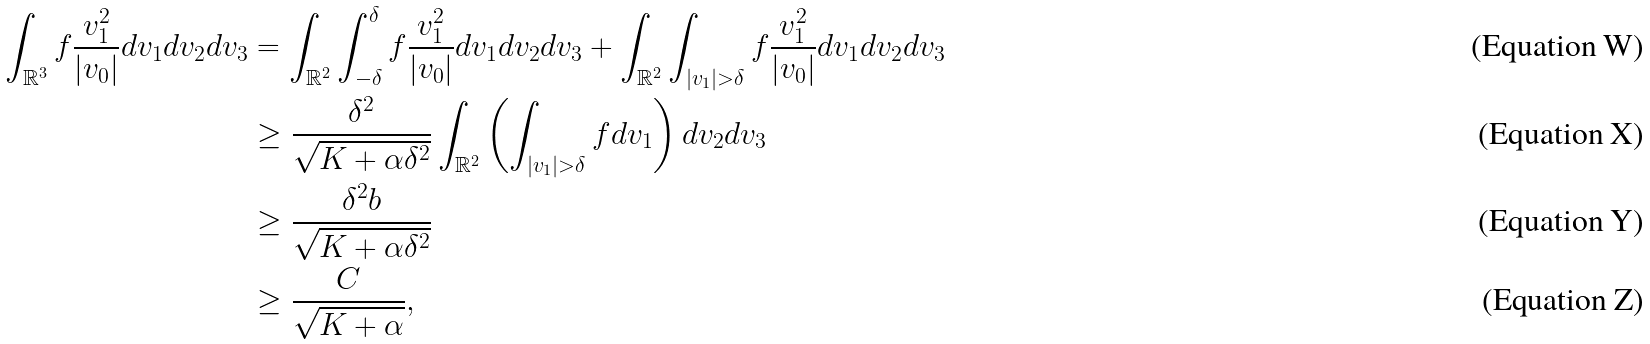Convert formula to latex. <formula><loc_0><loc_0><loc_500><loc_500>\int _ { \mathbb { R } ^ { 3 } } f \frac { v _ { 1 } ^ { 2 } } { | v _ { 0 } | } d v _ { 1 } d v _ { 2 } d v _ { 3 } & = \int _ { \mathbb { R } ^ { 2 } } \int _ { - \delta } ^ { \delta } f \frac { v _ { 1 } ^ { 2 } } { | v _ { 0 } | } d v _ { 1 } d v _ { 2 } d v _ { 3 } + \int _ { \mathbb { R } ^ { 2 } } \int _ { | v _ { 1 } | > \delta } f \frac { v _ { 1 } ^ { 2 } } { | v _ { 0 } | } d v _ { 1 } d v _ { 2 } d v _ { 3 } \\ & \geq \frac { \delta ^ { 2 } } { \sqrt { K + \alpha \delta ^ { 2 } } } \int _ { \mathbb { R } ^ { 2 } } \left ( \int _ { | v _ { 1 } | > \delta } f d v _ { 1 } \right ) d v _ { 2 } d v _ { 3 } \\ & \geq \frac { \delta ^ { 2 } b } { \sqrt { K + \alpha \delta ^ { 2 } } } \\ & \geq \frac { C } { \sqrt { K + \alpha } } ,</formula> 